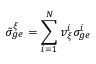Convert formula to latex. <formula><loc_0><loc_0><loc_500><loc_500>\tilde { \sigma } _ { g e } ^ { \xi } = \sum _ { i = 1 } ^ { N } v _ { \xi } ^ { i } \sigma _ { g e } ^ { i }</formula> 